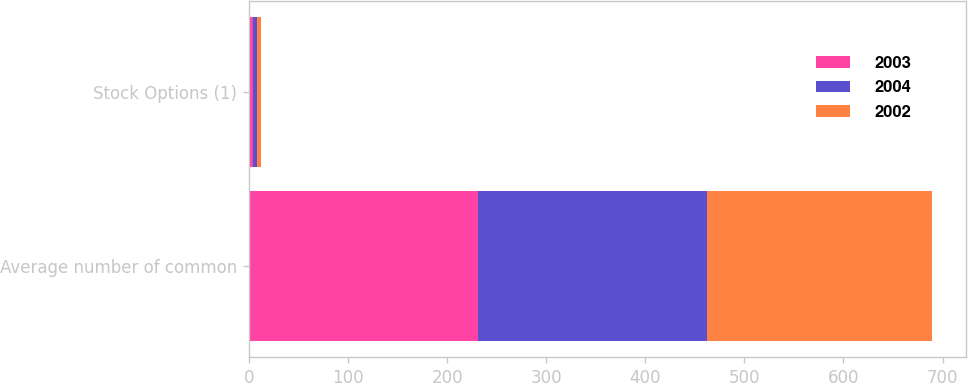Convert chart to OTSL. <chart><loc_0><loc_0><loc_500><loc_500><stacked_bar_chart><ecel><fcel>Average number of common<fcel>Stock Options (1)<nl><fcel>2003<fcel>231.2<fcel>4.3<nl><fcel>2004<fcel>231.1<fcel>4.1<nl><fcel>2002<fcel>227.3<fcel>3.9<nl></chart> 